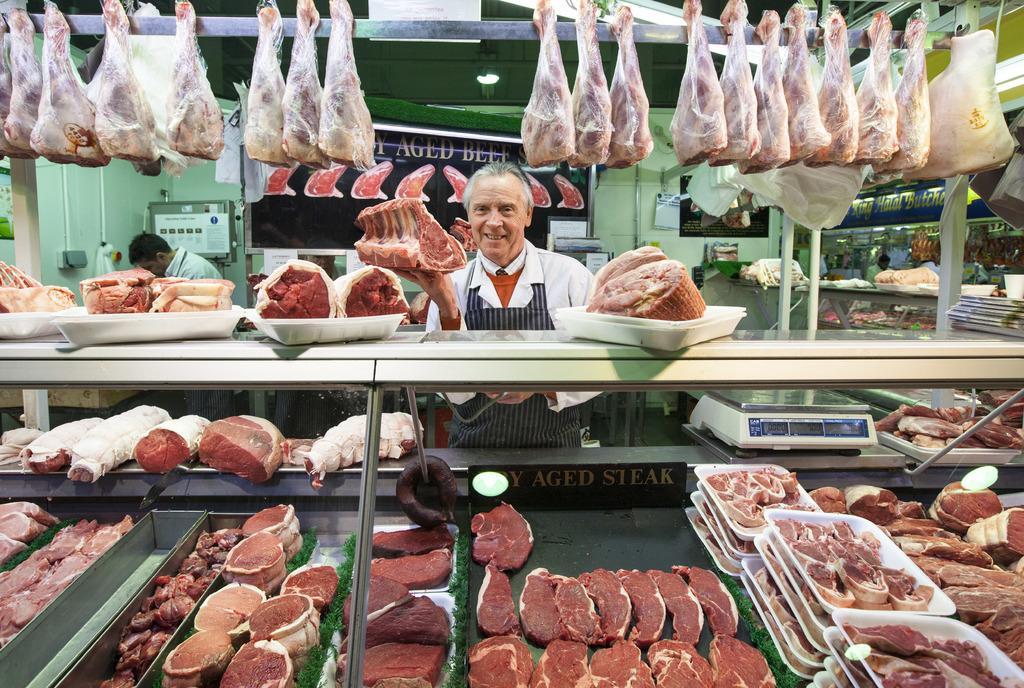How would you summarize this image in a sentence or two? In this image we can see a person, meat in the bowl, meat hanged and other objects. In the background of the image there are people, wall, board and other objects. At the bottom of the image there is meat in trays, bowls and other objects. 